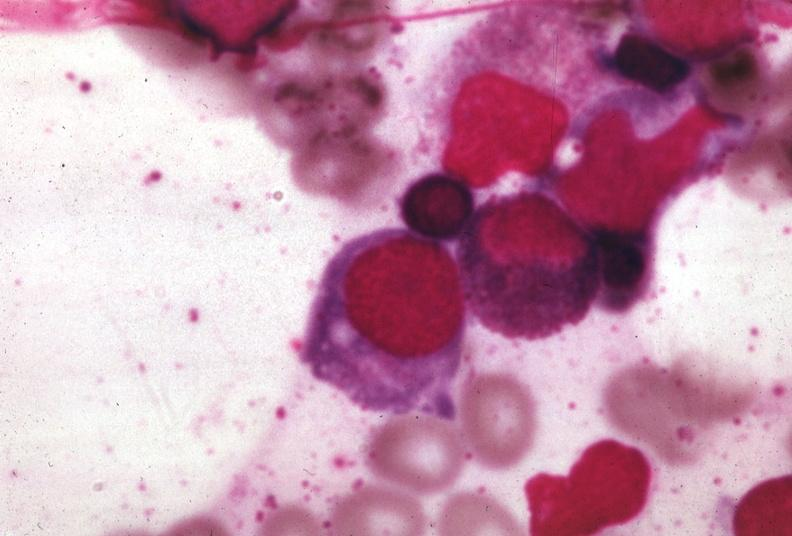does this image show wrights?
Answer the question using a single word or phrase. Yes 